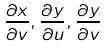Convert formula to latex. <formula><loc_0><loc_0><loc_500><loc_500>\frac { \partial x } { \partial v } , \frac { \partial y } { \partial u } , \frac { \partial y } { \partial v }</formula> 